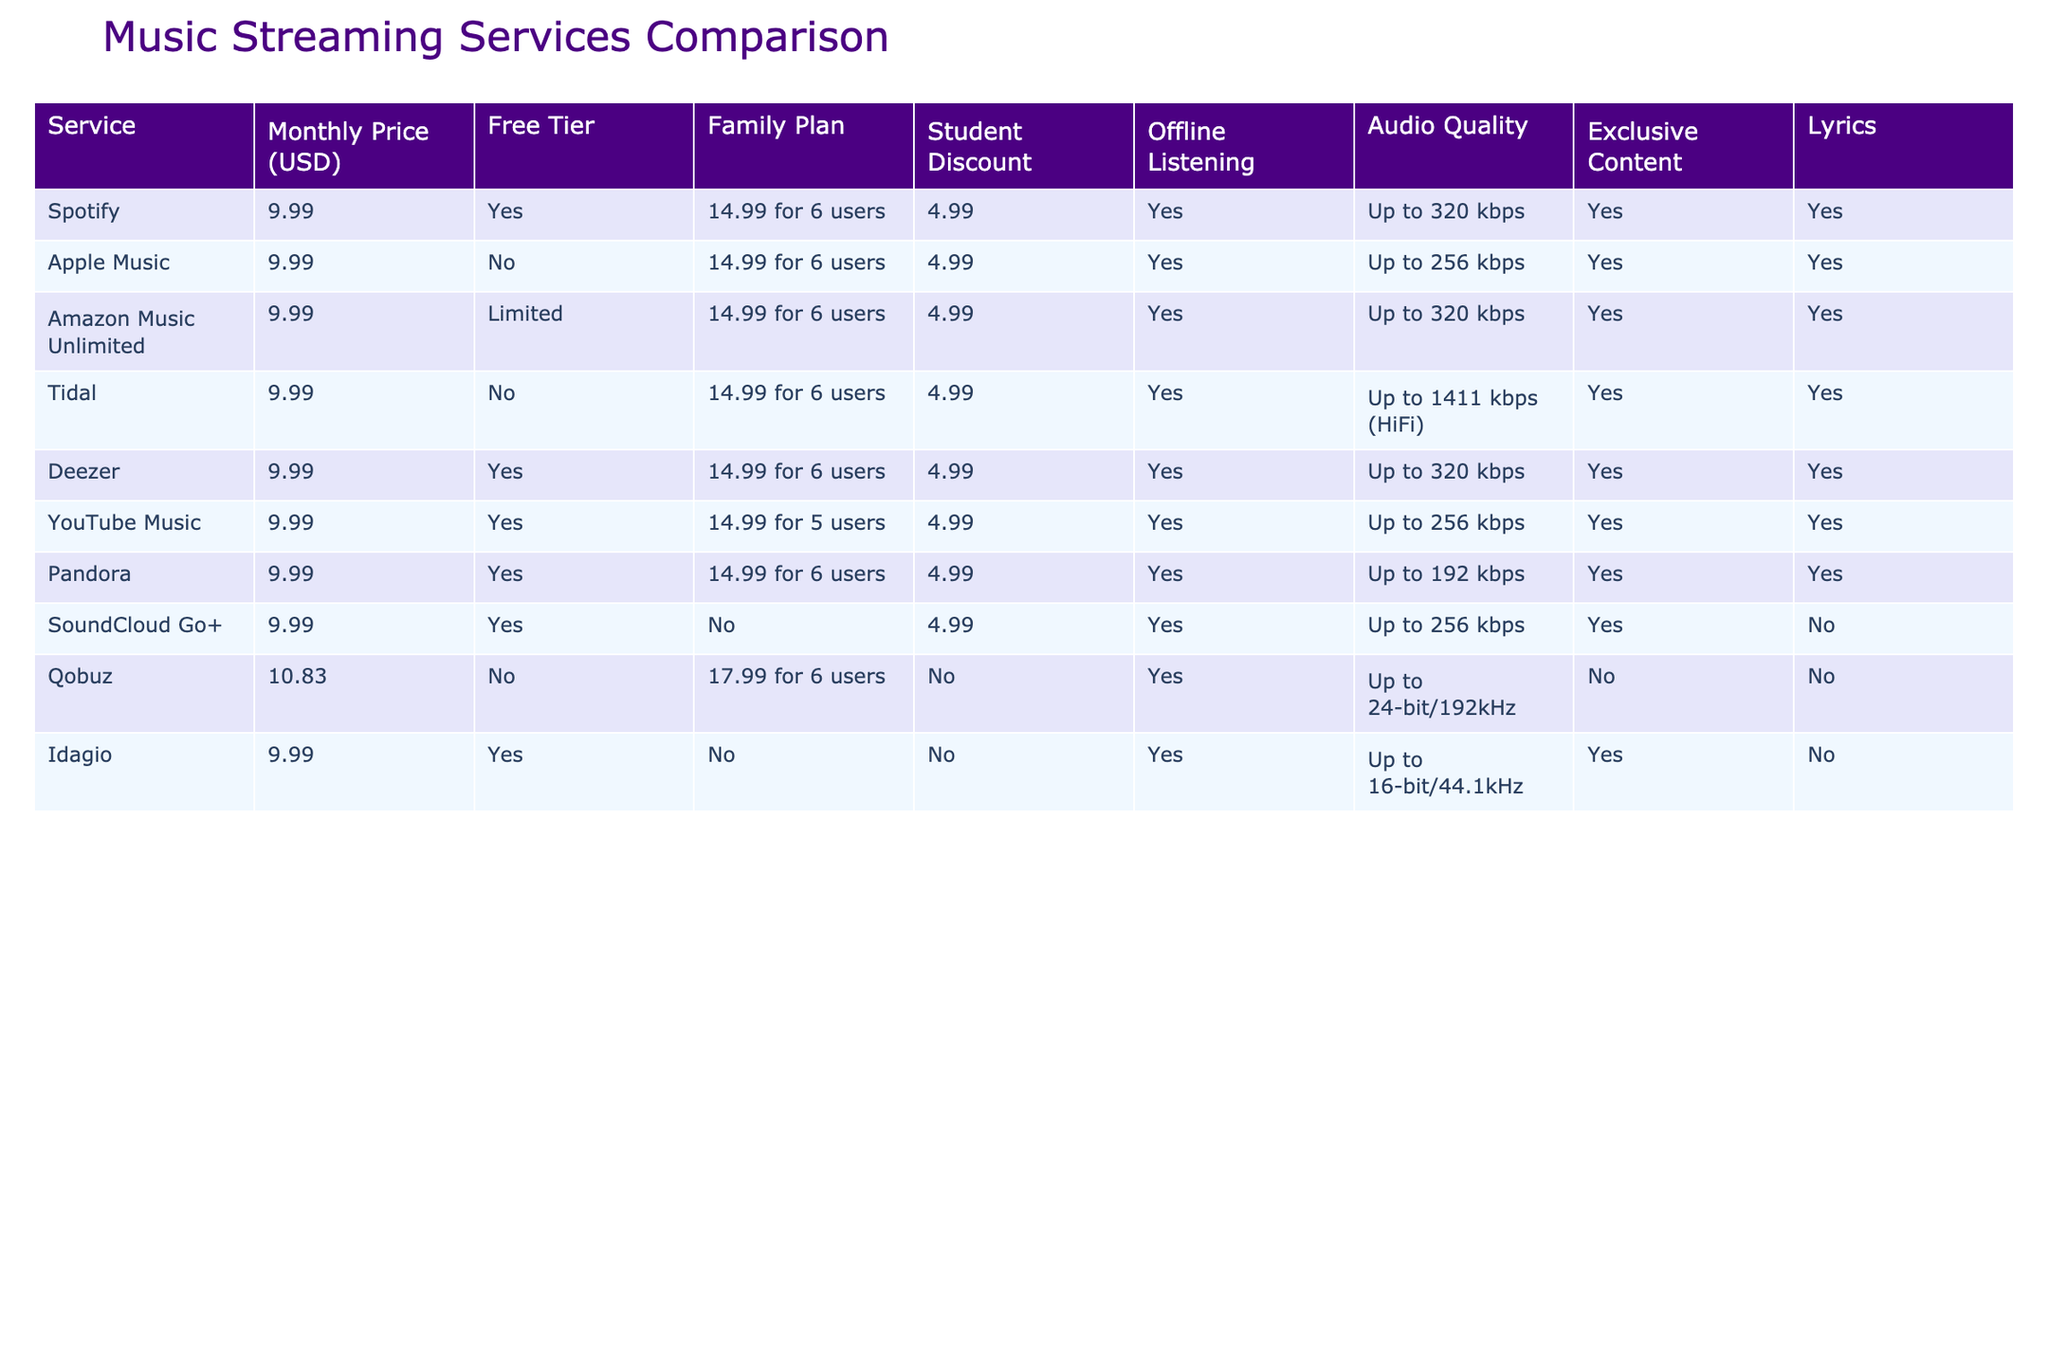What is the monthly price of Tidal? The table shows that Tidal has a monthly price of 9.99 USD.
Answer: 9.99 USD Does Apple Music offer a free tier? According to the table, Apple Music does not have a free tier, as indicated by "No" in that column.
Answer: No How many services offer offline listening? By examining the table, the services that offer offline listening are Spotify, Apple Music, Amazon Music Unlimited, Tidal, Deezer, YouTube Music, Pandora, SoundCloud Go+, and Idagio. That's a total of 8 services.
Answer: 8 What is the difference in audio quality between Pandora and Qobuz? The table lists Pandora with an audio quality of Up to 192 kbps and Qobuz with an audio quality of Up to 24-bit/192kHz. The difference in audio quality format makes Qobuz significantly superior, both in terms of bitrate and sampling rate.
Answer: Qobuz is superior in audio quality Is there a student discount for Idagio? The table shows that Idagio does not offer a student discount, as indicated by "No" in the relevant column.
Answer: No How many services have exclusive content? To find the number of services with exclusive content, I’ll check the column for exclusive content. Services that have exclusive content include Spotify, Apple Music, Amazon Music Unlimited, Tidal, Deezer, YouTube Music, and the total is 6 services.
Answer: 6 What is the average monthly price of the services listed? Adding the monthly prices: (9.99 + 9.99 + 9.99 + 9.99 + 9.99 + 9.99 + 9.99 + 10.83) = 79.93. There are 8 services, so the average monthly price is 79.93 / 8 ≈ 9.99.
Answer: 9.99 USD Which service has the highest audio quality? Looking at the audio quality column, Qobuz has the highest audio quality listed at Up to 24-bit/192kHz, which is superior to others.
Answer: Qobuz How much is the family plan for Deezer? The table shows that the family plan for Deezer is priced at 14.99 for 6 users.
Answer: 14.99 for 6 users 